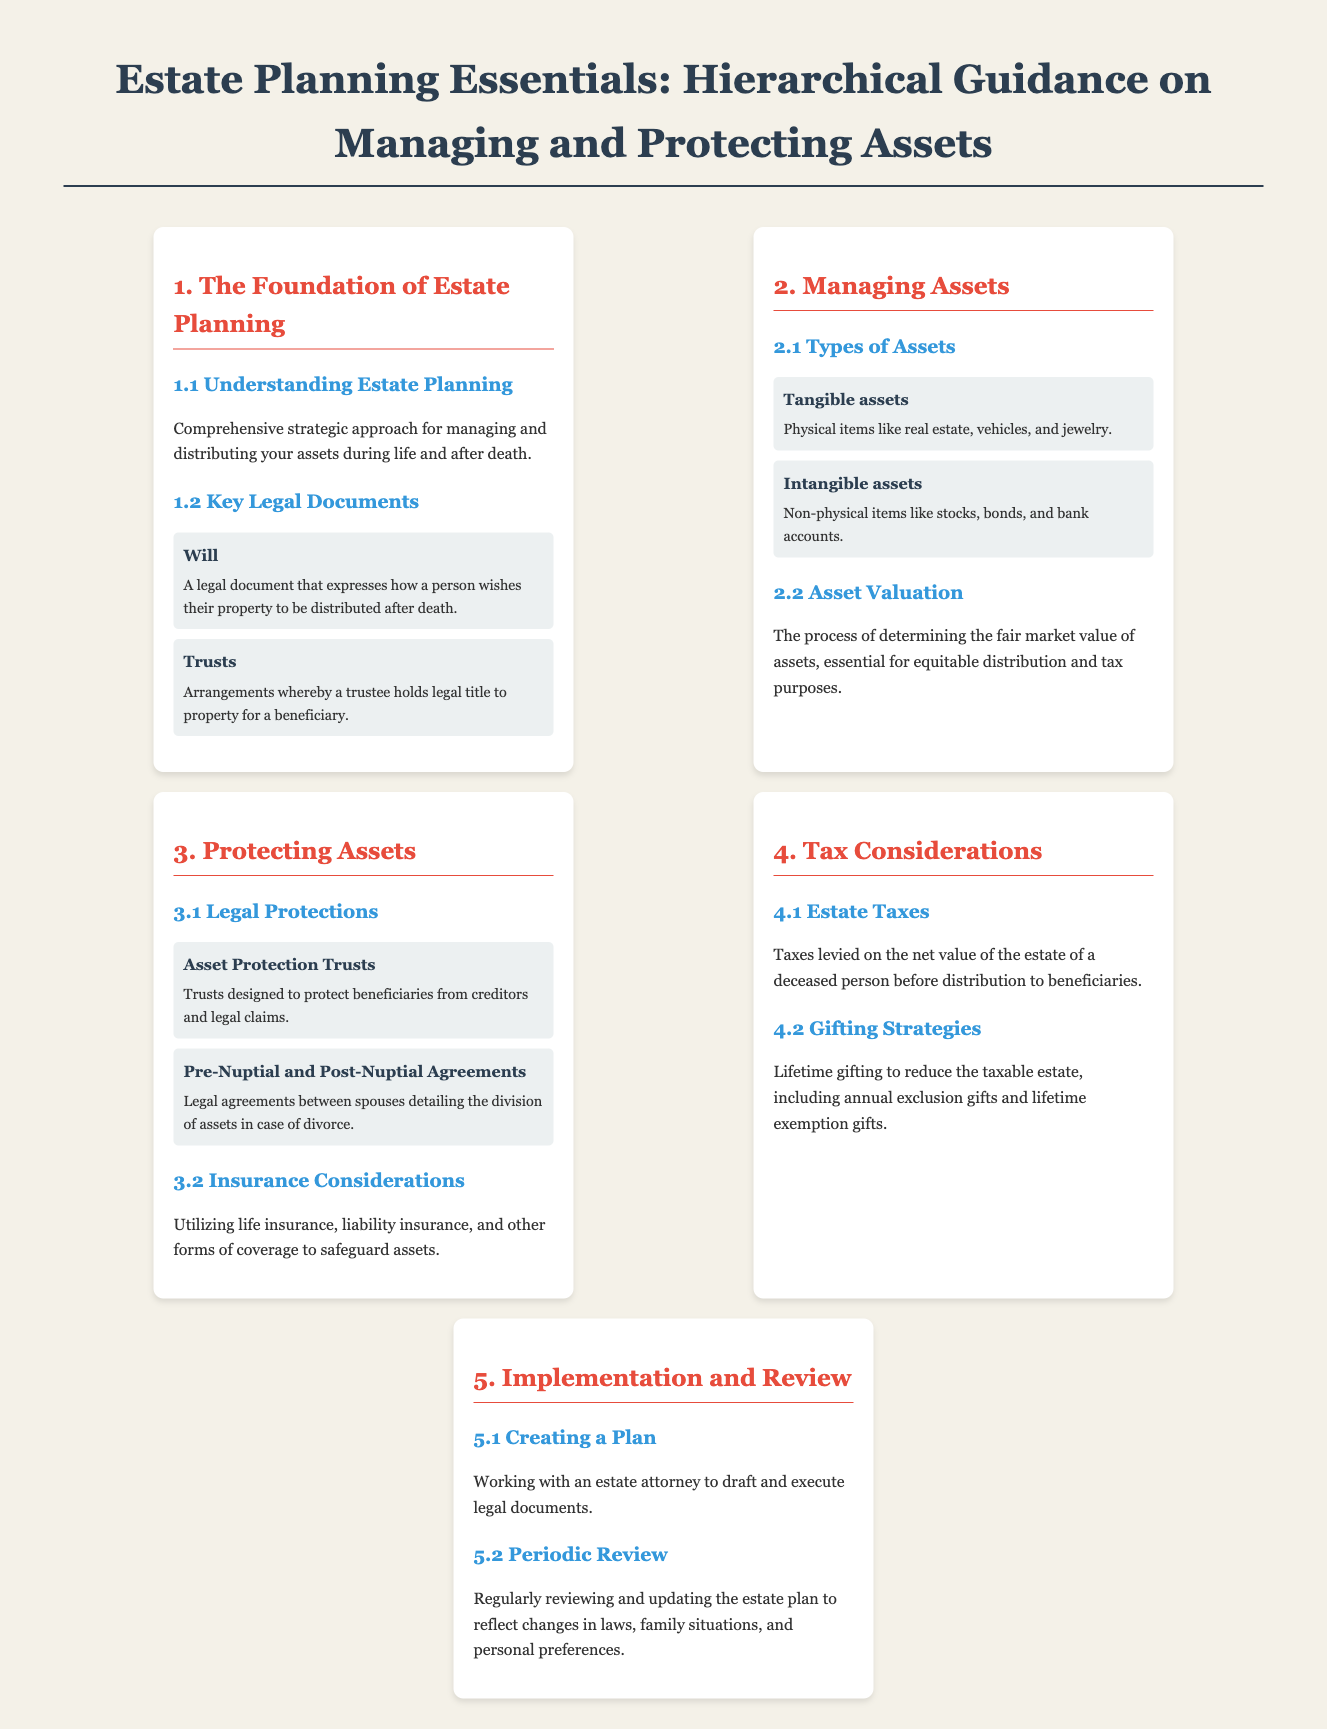What is the primary purpose of estate planning? The document states that estate planning is a comprehensive strategic approach for managing and distributing your assets during life and after death.
Answer: Managing and distributing assets What type of document expresses how property is distributed after death? The document identifies a will as the legal document that expresses how a person wishes their property to be distributed after death.
Answer: Will Name one type of asset mentioned in the document. The document lists tangible assets and intangible assets as types of assets; an example of tangible assets would be real estate.
Answer: Tangible assets What is the goal of asset valuation? The document explains that asset valuation is essential for equitable distribution and tax purposes, determining the fair market value of assets.
Answer: Fair market value determination What is one legal protection for assets highlighted in the infographic? The document mentions Asset Protection Trusts as trusts designed to protect beneficiaries from creditors and legal claims.
Answer: Asset Protection Trusts What type of insurance is considered important for safeguarding assets? The document talks about insurance considerations, including life insurance and liability insurance, to protect assets.
Answer: Life insurance What does periodic review involve in estate planning? The document states that periodic review entails regularly reviewing and updating the estate plan to reflect changes in laws, family situations, and personal preferences.
Answer: Updating the estate plan How can gifting strategies affect the taxable estate? The document explains that lifetime gifting can reduce the taxable estate, indicating that gifting strategies are utilized for tax benefits.
Answer: Reduce the taxable estate What are pre-nuptial agreements designed to address? The document outlines that pre-nuptial agreements are legal agreements between spouses detailing the division of assets in case of divorce.
Answer: Division of assets in case of divorce 